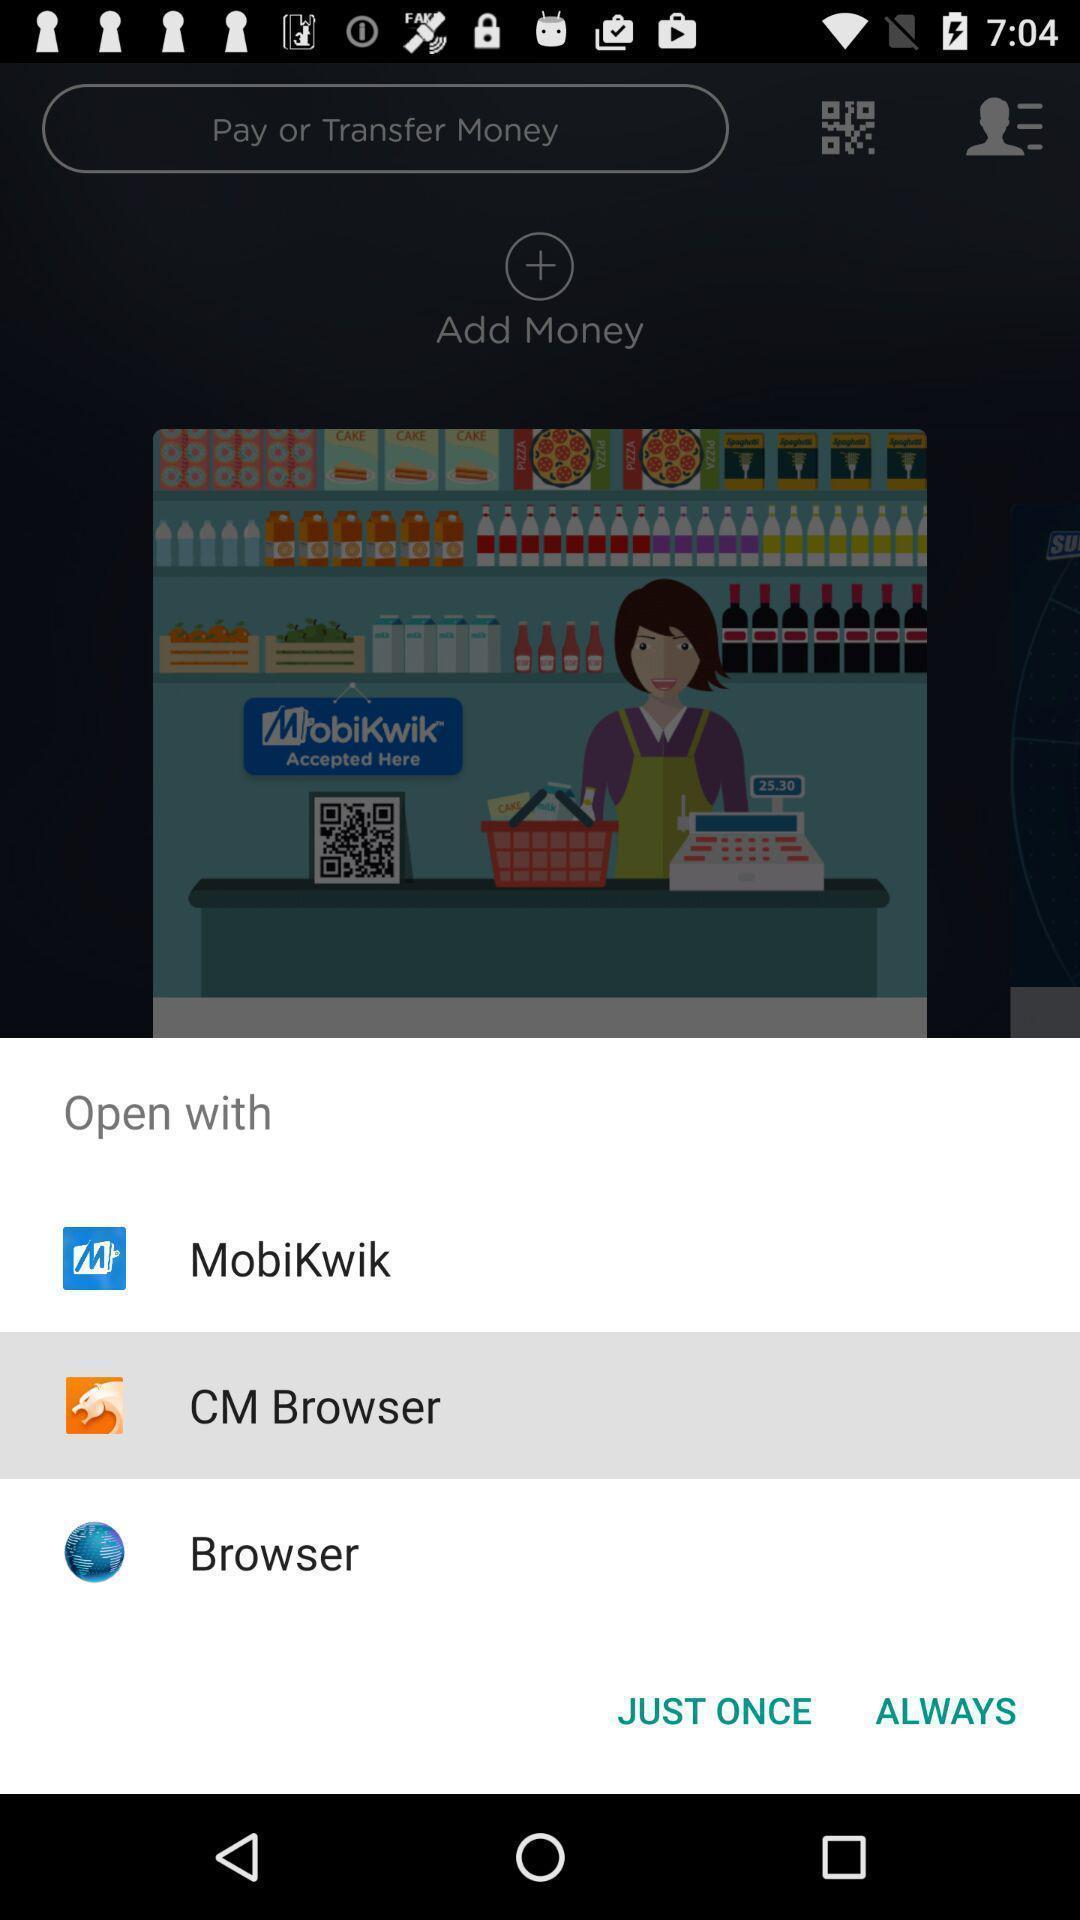What is the overall content of this screenshot? Pop up to open an app with various applications. 